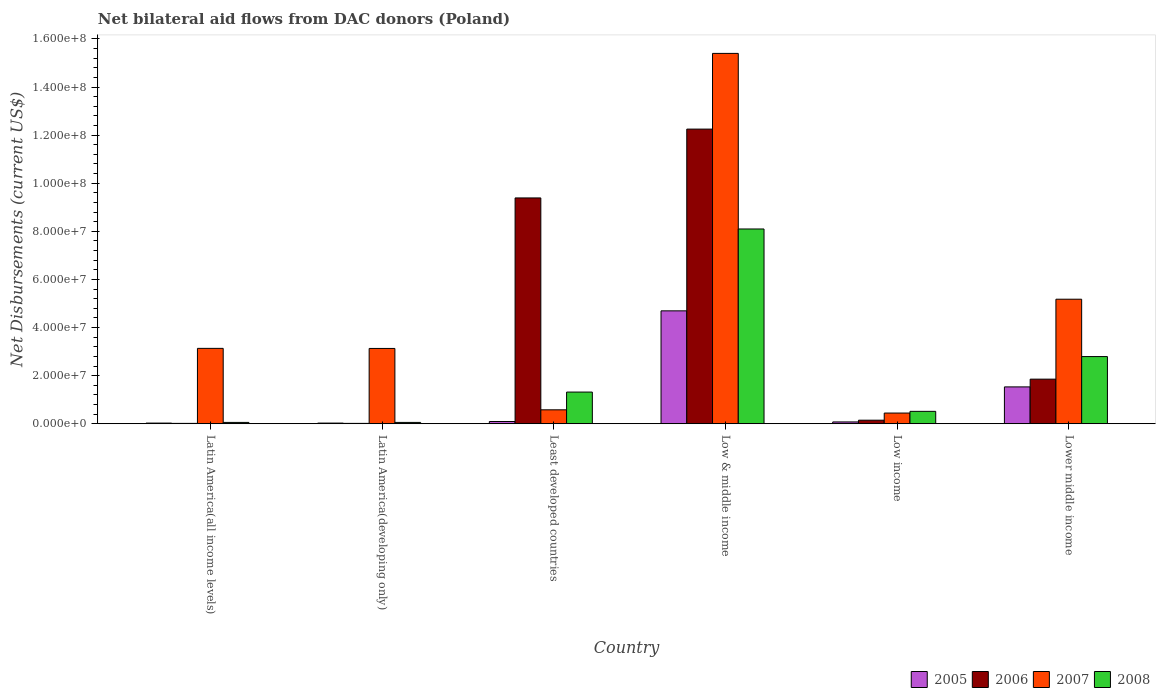How many groups of bars are there?
Provide a succinct answer. 6. Are the number of bars per tick equal to the number of legend labels?
Your answer should be compact. Yes. How many bars are there on the 2nd tick from the left?
Your response must be concise. 4. What is the label of the 2nd group of bars from the left?
Make the answer very short. Latin America(developing only). What is the net bilateral aid flows in 2005 in Low income?
Your answer should be very brief. 7.50e+05. Across all countries, what is the maximum net bilateral aid flows in 2008?
Offer a very short reply. 8.10e+07. In which country was the net bilateral aid flows in 2006 maximum?
Offer a terse response. Low & middle income. In which country was the net bilateral aid flows in 2008 minimum?
Keep it short and to the point. Latin America(all income levels). What is the total net bilateral aid flows in 2007 in the graph?
Your response must be concise. 2.79e+08. What is the difference between the net bilateral aid flows in 2005 in Least developed countries and the net bilateral aid flows in 2008 in Low & middle income?
Make the answer very short. -8.00e+07. What is the average net bilateral aid flows in 2005 per country?
Make the answer very short. 1.07e+07. What is the difference between the net bilateral aid flows of/in 2006 and net bilateral aid flows of/in 2008 in Low & middle income?
Ensure brevity in your answer.  4.15e+07. In how many countries, is the net bilateral aid flows in 2008 greater than 88000000 US$?
Your response must be concise. 0. What is the ratio of the net bilateral aid flows in 2007 in Latin America(all income levels) to that in Latin America(developing only)?
Offer a terse response. 1. Is the net bilateral aid flows in 2008 in Latin America(developing only) less than that in Lower middle income?
Keep it short and to the point. Yes. Is the difference between the net bilateral aid flows in 2006 in Latin America(all income levels) and Latin America(developing only) greater than the difference between the net bilateral aid flows in 2008 in Latin America(all income levels) and Latin America(developing only)?
Ensure brevity in your answer.  No. What is the difference between the highest and the second highest net bilateral aid flows in 2008?
Make the answer very short. 6.78e+07. What is the difference between the highest and the lowest net bilateral aid flows in 2007?
Your response must be concise. 1.50e+08. Is the sum of the net bilateral aid flows in 2007 in Least developed countries and Low income greater than the maximum net bilateral aid flows in 2005 across all countries?
Provide a short and direct response. No. Is it the case that in every country, the sum of the net bilateral aid flows in 2008 and net bilateral aid flows in 2006 is greater than the sum of net bilateral aid flows in 2005 and net bilateral aid flows in 2007?
Your answer should be compact. No. What does the 4th bar from the left in Low & middle income represents?
Give a very brief answer. 2008. Is it the case that in every country, the sum of the net bilateral aid flows in 2007 and net bilateral aid flows in 2005 is greater than the net bilateral aid flows in 2006?
Provide a short and direct response. No. Are all the bars in the graph horizontal?
Offer a very short reply. No. How many countries are there in the graph?
Your answer should be very brief. 6. Are the values on the major ticks of Y-axis written in scientific E-notation?
Offer a terse response. Yes. Where does the legend appear in the graph?
Make the answer very short. Bottom right. How many legend labels are there?
Your response must be concise. 4. How are the legend labels stacked?
Provide a succinct answer. Horizontal. What is the title of the graph?
Offer a very short reply. Net bilateral aid flows from DAC donors (Poland). What is the label or title of the X-axis?
Make the answer very short. Country. What is the label or title of the Y-axis?
Ensure brevity in your answer.  Net Disbursements (current US$). What is the Net Disbursements (current US$) of 2007 in Latin America(all income levels)?
Give a very brief answer. 3.13e+07. What is the Net Disbursements (current US$) of 2005 in Latin America(developing only)?
Make the answer very short. 2.70e+05. What is the Net Disbursements (current US$) in 2007 in Latin America(developing only)?
Provide a short and direct response. 3.13e+07. What is the Net Disbursements (current US$) of 2008 in Latin America(developing only)?
Your response must be concise. 5.50e+05. What is the Net Disbursements (current US$) of 2005 in Least developed countries?
Offer a terse response. 9.30e+05. What is the Net Disbursements (current US$) of 2006 in Least developed countries?
Keep it short and to the point. 9.39e+07. What is the Net Disbursements (current US$) in 2007 in Least developed countries?
Offer a very short reply. 5.79e+06. What is the Net Disbursements (current US$) of 2008 in Least developed countries?
Your answer should be compact. 1.32e+07. What is the Net Disbursements (current US$) of 2005 in Low & middle income?
Offer a terse response. 4.69e+07. What is the Net Disbursements (current US$) in 2006 in Low & middle income?
Provide a short and direct response. 1.23e+08. What is the Net Disbursements (current US$) of 2007 in Low & middle income?
Offer a terse response. 1.54e+08. What is the Net Disbursements (current US$) in 2008 in Low & middle income?
Give a very brief answer. 8.10e+07. What is the Net Disbursements (current US$) of 2005 in Low income?
Offer a terse response. 7.50e+05. What is the Net Disbursements (current US$) in 2006 in Low income?
Provide a short and direct response. 1.47e+06. What is the Net Disbursements (current US$) of 2007 in Low income?
Make the answer very short. 4.44e+06. What is the Net Disbursements (current US$) of 2008 in Low income?
Ensure brevity in your answer.  5.15e+06. What is the Net Disbursements (current US$) of 2005 in Lower middle income?
Provide a succinct answer. 1.53e+07. What is the Net Disbursements (current US$) in 2006 in Lower middle income?
Provide a short and direct response. 1.85e+07. What is the Net Disbursements (current US$) in 2007 in Lower middle income?
Give a very brief answer. 5.18e+07. What is the Net Disbursements (current US$) of 2008 in Lower middle income?
Keep it short and to the point. 2.79e+07. Across all countries, what is the maximum Net Disbursements (current US$) in 2005?
Ensure brevity in your answer.  4.69e+07. Across all countries, what is the maximum Net Disbursements (current US$) in 2006?
Your answer should be compact. 1.23e+08. Across all countries, what is the maximum Net Disbursements (current US$) in 2007?
Provide a short and direct response. 1.54e+08. Across all countries, what is the maximum Net Disbursements (current US$) in 2008?
Your response must be concise. 8.10e+07. Across all countries, what is the minimum Net Disbursements (current US$) of 2005?
Your answer should be very brief. 2.70e+05. Across all countries, what is the minimum Net Disbursements (current US$) in 2006?
Your response must be concise. 1.50e+05. Across all countries, what is the minimum Net Disbursements (current US$) of 2007?
Your response must be concise. 4.44e+06. Across all countries, what is the minimum Net Disbursements (current US$) of 2008?
Ensure brevity in your answer.  5.50e+05. What is the total Net Disbursements (current US$) in 2005 in the graph?
Provide a short and direct response. 6.45e+07. What is the total Net Disbursements (current US$) of 2006 in the graph?
Provide a succinct answer. 2.37e+08. What is the total Net Disbursements (current US$) of 2007 in the graph?
Your answer should be very brief. 2.79e+08. What is the total Net Disbursements (current US$) in 2008 in the graph?
Your answer should be very brief. 1.28e+08. What is the difference between the Net Disbursements (current US$) of 2005 in Latin America(all income levels) and that in Latin America(developing only)?
Offer a terse response. 0. What is the difference between the Net Disbursements (current US$) in 2006 in Latin America(all income levels) and that in Latin America(developing only)?
Provide a short and direct response. 0. What is the difference between the Net Disbursements (current US$) in 2007 in Latin America(all income levels) and that in Latin America(developing only)?
Your answer should be compact. 3.00e+04. What is the difference between the Net Disbursements (current US$) of 2008 in Latin America(all income levels) and that in Latin America(developing only)?
Your response must be concise. 0. What is the difference between the Net Disbursements (current US$) in 2005 in Latin America(all income levels) and that in Least developed countries?
Ensure brevity in your answer.  -6.60e+05. What is the difference between the Net Disbursements (current US$) of 2006 in Latin America(all income levels) and that in Least developed countries?
Ensure brevity in your answer.  -9.37e+07. What is the difference between the Net Disbursements (current US$) of 2007 in Latin America(all income levels) and that in Least developed countries?
Your answer should be compact. 2.56e+07. What is the difference between the Net Disbursements (current US$) of 2008 in Latin America(all income levels) and that in Least developed countries?
Your response must be concise. -1.26e+07. What is the difference between the Net Disbursements (current US$) of 2005 in Latin America(all income levels) and that in Low & middle income?
Make the answer very short. -4.67e+07. What is the difference between the Net Disbursements (current US$) in 2006 in Latin America(all income levels) and that in Low & middle income?
Your response must be concise. -1.22e+08. What is the difference between the Net Disbursements (current US$) in 2007 in Latin America(all income levels) and that in Low & middle income?
Your answer should be very brief. -1.23e+08. What is the difference between the Net Disbursements (current US$) in 2008 in Latin America(all income levels) and that in Low & middle income?
Keep it short and to the point. -8.04e+07. What is the difference between the Net Disbursements (current US$) of 2005 in Latin America(all income levels) and that in Low income?
Provide a succinct answer. -4.80e+05. What is the difference between the Net Disbursements (current US$) of 2006 in Latin America(all income levels) and that in Low income?
Your answer should be compact. -1.32e+06. What is the difference between the Net Disbursements (current US$) in 2007 in Latin America(all income levels) and that in Low income?
Provide a short and direct response. 2.69e+07. What is the difference between the Net Disbursements (current US$) of 2008 in Latin America(all income levels) and that in Low income?
Offer a terse response. -4.60e+06. What is the difference between the Net Disbursements (current US$) in 2005 in Latin America(all income levels) and that in Lower middle income?
Make the answer very short. -1.50e+07. What is the difference between the Net Disbursements (current US$) of 2006 in Latin America(all income levels) and that in Lower middle income?
Your answer should be compact. -1.84e+07. What is the difference between the Net Disbursements (current US$) in 2007 in Latin America(all income levels) and that in Lower middle income?
Keep it short and to the point. -2.04e+07. What is the difference between the Net Disbursements (current US$) of 2008 in Latin America(all income levels) and that in Lower middle income?
Your answer should be very brief. -2.74e+07. What is the difference between the Net Disbursements (current US$) in 2005 in Latin America(developing only) and that in Least developed countries?
Make the answer very short. -6.60e+05. What is the difference between the Net Disbursements (current US$) of 2006 in Latin America(developing only) and that in Least developed countries?
Ensure brevity in your answer.  -9.37e+07. What is the difference between the Net Disbursements (current US$) in 2007 in Latin America(developing only) and that in Least developed countries?
Offer a terse response. 2.55e+07. What is the difference between the Net Disbursements (current US$) in 2008 in Latin America(developing only) and that in Least developed countries?
Ensure brevity in your answer.  -1.26e+07. What is the difference between the Net Disbursements (current US$) in 2005 in Latin America(developing only) and that in Low & middle income?
Offer a very short reply. -4.67e+07. What is the difference between the Net Disbursements (current US$) of 2006 in Latin America(developing only) and that in Low & middle income?
Provide a short and direct response. -1.22e+08. What is the difference between the Net Disbursements (current US$) of 2007 in Latin America(developing only) and that in Low & middle income?
Offer a very short reply. -1.23e+08. What is the difference between the Net Disbursements (current US$) in 2008 in Latin America(developing only) and that in Low & middle income?
Keep it short and to the point. -8.04e+07. What is the difference between the Net Disbursements (current US$) of 2005 in Latin America(developing only) and that in Low income?
Offer a terse response. -4.80e+05. What is the difference between the Net Disbursements (current US$) of 2006 in Latin America(developing only) and that in Low income?
Provide a succinct answer. -1.32e+06. What is the difference between the Net Disbursements (current US$) of 2007 in Latin America(developing only) and that in Low income?
Offer a very short reply. 2.69e+07. What is the difference between the Net Disbursements (current US$) of 2008 in Latin America(developing only) and that in Low income?
Ensure brevity in your answer.  -4.60e+06. What is the difference between the Net Disbursements (current US$) in 2005 in Latin America(developing only) and that in Lower middle income?
Your answer should be compact. -1.50e+07. What is the difference between the Net Disbursements (current US$) in 2006 in Latin America(developing only) and that in Lower middle income?
Make the answer very short. -1.84e+07. What is the difference between the Net Disbursements (current US$) in 2007 in Latin America(developing only) and that in Lower middle income?
Your answer should be compact. -2.05e+07. What is the difference between the Net Disbursements (current US$) in 2008 in Latin America(developing only) and that in Lower middle income?
Your answer should be compact. -2.74e+07. What is the difference between the Net Disbursements (current US$) in 2005 in Least developed countries and that in Low & middle income?
Keep it short and to the point. -4.60e+07. What is the difference between the Net Disbursements (current US$) of 2006 in Least developed countries and that in Low & middle income?
Make the answer very short. -2.86e+07. What is the difference between the Net Disbursements (current US$) of 2007 in Least developed countries and that in Low & middle income?
Make the answer very short. -1.48e+08. What is the difference between the Net Disbursements (current US$) in 2008 in Least developed countries and that in Low & middle income?
Your response must be concise. -6.78e+07. What is the difference between the Net Disbursements (current US$) in 2006 in Least developed countries and that in Low income?
Your answer should be very brief. 9.24e+07. What is the difference between the Net Disbursements (current US$) of 2007 in Least developed countries and that in Low income?
Your answer should be compact. 1.35e+06. What is the difference between the Net Disbursements (current US$) of 2008 in Least developed countries and that in Low income?
Your answer should be very brief. 8.02e+06. What is the difference between the Net Disbursements (current US$) of 2005 in Least developed countries and that in Lower middle income?
Provide a short and direct response. -1.44e+07. What is the difference between the Net Disbursements (current US$) in 2006 in Least developed countries and that in Lower middle income?
Offer a very short reply. 7.54e+07. What is the difference between the Net Disbursements (current US$) in 2007 in Least developed countries and that in Lower middle income?
Give a very brief answer. -4.60e+07. What is the difference between the Net Disbursements (current US$) of 2008 in Least developed countries and that in Lower middle income?
Your answer should be compact. -1.48e+07. What is the difference between the Net Disbursements (current US$) of 2005 in Low & middle income and that in Low income?
Provide a succinct answer. 4.62e+07. What is the difference between the Net Disbursements (current US$) of 2006 in Low & middle income and that in Low income?
Provide a short and direct response. 1.21e+08. What is the difference between the Net Disbursements (current US$) of 2007 in Low & middle income and that in Low income?
Provide a short and direct response. 1.50e+08. What is the difference between the Net Disbursements (current US$) in 2008 in Low & middle income and that in Low income?
Offer a very short reply. 7.58e+07. What is the difference between the Net Disbursements (current US$) of 2005 in Low & middle income and that in Lower middle income?
Your answer should be compact. 3.16e+07. What is the difference between the Net Disbursements (current US$) in 2006 in Low & middle income and that in Lower middle income?
Provide a succinct answer. 1.04e+08. What is the difference between the Net Disbursements (current US$) of 2007 in Low & middle income and that in Lower middle income?
Your response must be concise. 1.02e+08. What is the difference between the Net Disbursements (current US$) of 2008 in Low & middle income and that in Lower middle income?
Ensure brevity in your answer.  5.30e+07. What is the difference between the Net Disbursements (current US$) in 2005 in Low income and that in Lower middle income?
Provide a succinct answer. -1.46e+07. What is the difference between the Net Disbursements (current US$) of 2006 in Low income and that in Lower middle income?
Your answer should be compact. -1.71e+07. What is the difference between the Net Disbursements (current US$) in 2007 in Low income and that in Lower middle income?
Make the answer very short. -4.73e+07. What is the difference between the Net Disbursements (current US$) in 2008 in Low income and that in Lower middle income?
Provide a succinct answer. -2.28e+07. What is the difference between the Net Disbursements (current US$) of 2005 in Latin America(all income levels) and the Net Disbursements (current US$) of 2006 in Latin America(developing only)?
Your answer should be compact. 1.20e+05. What is the difference between the Net Disbursements (current US$) in 2005 in Latin America(all income levels) and the Net Disbursements (current US$) in 2007 in Latin America(developing only)?
Provide a succinct answer. -3.10e+07. What is the difference between the Net Disbursements (current US$) of 2005 in Latin America(all income levels) and the Net Disbursements (current US$) of 2008 in Latin America(developing only)?
Your response must be concise. -2.80e+05. What is the difference between the Net Disbursements (current US$) in 2006 in Latin America(all income levels) and the Net Disbursements (current US$) in 2007 in Latin America(developing only)?
Make the answer very short. -3.12e+07. What is the difference between the Net Disbursements (current US$) of 2006 in Latin America(all income levels) and the Net Disbursements (current US$) of 2008 in Latin America(developing only)?
Your answer should be compact. -4.00e+05. What is the difference between the Net Disbursements (current US$) in 2007 in Latin America(all income levels) and the Net Disbursements (current US$) in 2008 in Latin America(developing only)?
Offer a very short reply. 3.08e+07. What is the difference between the Net Disbursements (current US$) in 2005 in Latin America(all income levels) and the Net Disbursements (current US$) in 2006 in Least developed countries?
Offer a very short reply. -9.36e+07. What is the difference between the Net Disbursements (current US$) in 2005 in Latin America(all income levels) and the Net Disbursements (current US$) in 2007 in Least developed countries?
Provide a short and direct response. -5.52e+06. What is the difference between the Net Disbursements (current US$) in 2005 in Latin America(all income levels) and the Net Disbursements (current US$) in 2008 in Least developed countries?
Offer a very short reply. -1.29e+07. What is the difference between the Net Disbursements (current US$) of 2006 in Latin America(all income levels) and the Net Disbursements (current US$) of 2007 in Least developed countries?
Provide a succinct answer. -5.64e+06. What is the difference between the Net Disbursements (current US$) in 2006 in Latin America(all income levels) and the Net Disbursements (current US$) in 2008 in Least developed countries?
Provide a short and direct response. -1.30e+07. What is the difference between the Net Disbursements (current US$) of 2007 in Latin America(all income levels) and the Net Disbursements (current US$) of 2008 in Least developed countries?
Your response must be concise. 1.82e+07. What is the difference between the Net Disbursements (current US$) of 2005 in Latin America(all income levels) and the Net Disbursements (current US$) of 2006 in Low & middle income?
Ensure brevity in your answer.  -1.22e+08. What is the difference between the Net Disbursements (current US$) in 2005 in Latin America(all income levels) and the Net Disbursements (current US$) in 2007 in Low & middle income?
Your response must be concise. -1.54e+08. What is the difference between the Net Disbursements (current US$) in 2005 in Latin America(all income levels) and the Net Disbursements (current US$) in 2008 in Low & middle income?
Your answer should be very brief. -8.07e+07. What is the difference between the Net Disbursements (current US$) in 2006 in Latin America(all income levels) and the Net Disbursements (current US$) in 2007 in Low & middle income?
Make the answer very short. -1.54e+08. What is the difference between the Net Disbursements (current US$) in 2006 in Latin America(all income levels) and the Net Disbursements (current US$) in 2008 in Low & middle income?
Ensure brevity in your answer.  -8.08e+07. What is the difference between the Net Disbursements (current US$) in 2007 in Latin America(all income levels) and the Net Disbursements (current US$) in 2008 in Low & middle income?
Your response must be concise. -4.96e+07. What is the difference between the Net Disbursements (current US$) in 2005 in Latin America(all income levels) and the Net Disbursements (current US$) in 2006 in Low income?
Offer a very short reply. -1.20e+06. What is the difference between the Net Disbursements (current US$) of 2005 in Latin America(all income levels) and the Net Disbursements (current US$) of 2007 in Low income?
Ensure brevity in your answer.  -4.17e+06. What is the difference between the Net Disbursements (current US$) of 2005 in Latin America(all income levels) and the Net Disbursements (current US$) of 2008 in Low income?
Give a very brief answer. -4.88e+06. What is the difference between the Net Disbursements (current US$) of 2006 in Latin America(all income levels) and the Net Disbursements (current US$) of 2007 in Low income?
Make the answer very short. -4.29e+06. What is the difference between the Net Disbursements (current US$) in 2006 in Latin America(all income levels) and the Net Disbursements (current US$) in 2008 in Low income?
Your answer should be very brief. -5.00e+06. What is the difference between the Net Disbursements (current US$) of 2007 in Latin America(all income levels) and the Net Disbursements (current US$) of 2008 in Low income?
Your answer should be compact. 2.62e+07. What is the difference between the Net Disbursements (current US$) in 2005 in Latin America(all income levels) and the Net Disbursements (current US$) in 2006 in Lower middle income?
Provide a short and direct response. -1.83e+07. What is the difference between the Net Disbursements (current US$) of 2005 in Latin America(all income levels) and the Net Disbursements (current US$) of 2007 in Lower middle income?
Offer a very short reply. -5.15e+07. What is the difference between the Net Disbursements (current US$) in 2005 in Latin America(all income levels) and the Net Disbursements (current US$) in 2008 in Lower middle income?
Offer a very short reply. -2.77e+07. What is the difference between the Net Disbursements (current US$) of 2006 in Latin America(all income levels) and the Net Disbursements (current US$) of 2007 in Lower middle income?
Your answer should be compact. -5.16e+07. What is the difference between the Net Disbursements (current US$) in 2006 in Latin America(all income levels) and the Net Disbursements (current US$) in 2008 in Lower middle income?
Give a very brief answer. -2.78e+07. What is the difference between the Net Disbursements (current US$) in 2007 in Latin America(all income levels) and the Net Disbursements (current US$) in 2008 in Lower middle income?
Ensure brevity in your answer.  3.41e+06. What is the difference between the Net Disbursements (current US$) of 2005 in Latin America(developing only) and the Net Disbursements (current US$) of 2006 in Least developed countries?
Your answer should be compact. -9.36e+07. What is the difference between the Net Disbursements (current US$) in 2005 in Latin America(developing only) and the Net Disbursements (current US$) in 2007 in Least developed countries?
Give a very brief answer. -5.52e+06. What is the difference between the Net Disbursements (current US$) in 2005 in Latin America(developing only) and the Net Disbursements (current US$) in 2008 in Least developed countries?
Offer a very short reply. -1.29e+07. What is the difference between the Net Disbursements (current US$) of 2006 in Latin America(developing only) and the Net Disbursements (current US$) of 2007 in Least developed countries?
Offer a terse response. -5.64e+06. What is the difference between the Net Disbursements (current US$) in 2006 in Latin America(developing only) and the Net Disbursements (current US$) in 2008 in Least developed countries?
Offer a terse response. -1.30e+07. What is the difference between the Net Disbursements (current US$) in 2007 in Latin America(developing only) and the Net Disbursements (current US$) in 2008 in Least developed countries?
Give a very brief answer. 1.81e+07. What is the difference between the Net Disbursements (current US$) in 2005 in Latin America(developing only) and the Net Disbursements (current US$) in 2006 in Low & middle income?
Your answer should be compact. -1.22e+08. What is the difference between the Net Disbursements (current US$) of 2005 in Latin America(developing only) and the Net Disbursements (current US$) of 2007 in Low & middle income?
Ensure brevity in your answer.  -1.54e+08. What is the difference between the Net Disbursements (current US$) of 2005 in Latin America(developing only) and the Net Disbursements (current US$) of 2008 in Low & middle income?
Offer a very short reply. -8.07e+07. What is the difference between the Net Disbursements (current US$) of 2006 in Latin America(developing only) and the Net Disbursements (current US$) of 2007 in Low & middle income?
Provide a succinct answer. -1.54e+08. What is the difference between the Net Disbursements (current US$) of 2006 in Latin America(developing only) and the Net Disbursements (current US$) of 2008 in Low & middle income?
Provide a short and direct response. -8.08e+07. What is the difference between the Net Disbursements (current US$) in 2007 in Latin America(developing only) and the Net Disbursements (current US$) in 2008 in Low & middle income?
Your answer should be very brief. -4.97e+07. What is the difference between the Net Disbursements (current US$) in 2005 in Latin America(developing only) and the Net Disbursements (current US$) in 2006 in Low income?
Your response must be concise. -1.20e+06. What is the difference between the Net Disbursements (current US$) in 2005 in Latin America(developing only) and the Net Disbursements (current US$) in 2007 in Low income?
Your response must be concise. -4.17e+06. What is the difference between the Net Disbursements (current US$) of 2005 in Latin America(developing only) and the Net Disbursements (current US$) of 2008 in Low income?
Provide a short and direct response. -4.88e+06. What is the difference between the Net Disbursements (current US$) of 2006 in Latin America(developing only) and the Net Disbursements (current US$) of 2007 in Low income?
Provide a succinct answer. -4.29e+06. What is the difference between the Net Disbursements (current US$) of 2006 in Latin America(developing only) and the Net Disbursements (current US$) of 2008 in Low income?
Your answer should be compact. -5.00e+06. What is the difference between the Net Disbursements (current US$) of 2007 in Latin America(developing only) and the Net Disbursements (current US$) of 2008 in Low income?
Ensure brevity in your answer.  2.62e+07. What is the difference between the Net Disbursements (current US$) in 2005 in Latin America(developing only) and the Net Disbursements (current US$) in 2006 in Lower middle income?
Offer a terse response. -1.83e+07. What is the difference between the Net Disbursements (current US$) in 2005 in Latin America(developing only) and the Net Disbursements (current US$) in 2007 in Lower middle income?
Make the answer very short. -5.15e+07. What is the difference between the Net Disbursements (current US$) of 2005 in Latin America(developing only) and the Net Disbursements (current US$) of 2008 in Lower middle income?
Give a very brief answer. -2.77e+07. What is the difference between the Net Disbursements (current US$) in 2006 in Latin America(developing only) and the Net Disbursements (current US$) in 2007 in Lower middle income?
Keep it short and to the point. -5.16e+07. What is the difference between the Net Disbursements (current US$) of 2006 in Latin America(developing only) and the Net Disbursements (current US$) of 2008 in Lower middle income?
Ensure brevity in your answer.  -2.78e+07. What is the difference between the Net Disbursements (current US$) in 2007 in Latin America(developing only) and the Net Disbursements (current US$) in 2008 in Lower middle income?
Keep it short and to the point. 3.38e+06. What is the difference between the Net Disbursements (current US$) in 2005 in Least developed countries and the Net Disbursements (current US$) in 2006 in Low & middle income?
Make the answer very short. -1.22e+08. What is the difference between the Net Disbursements (current US$) of 2005 in Least developed countries and the Net Disbursements (current US$) of 2007 in Low & middle income?
Offer a terse response. -1.53e+08. What is the difference between the Net Disbursements (current US$) of 2005 in Least developed countries and the Net Disbursements (current US$) of 2008 in Low & middle income?
Your answer should be compact. -8.00e+07. What is the difference between the Net Disbursements (current US$) in 2006 in Least developed countries and the Net Disbursements (current US$) in 2007 in Low & middle income?
Your answer should be compact. -6.01e+07. What is the difference between the Net Disbursements (current US$) in 2006 in Least developed countries and the Net Disbursements (current US$) in 2008 in Low & middle income?
Ensure brevity in your answer.  1.29e+07. What is the difference between the Net Disbursements (current US$) in 2007 in Least developed countries and the Net Disbursements (current US$) in 2008 in Low & middle income?
Your answer should be very brief. -7.52e+07. What is the difference between the Net Disbursements (current US$) in 2005 in Least developed countries and the Net Disbursements (current US$) in 2006 in Low income?
Provide a short and direct response. -5.40e+05. What is the difference between the Net Disbursements (current US$) in 2005 in Least developed countries and the Net Disbursements (current US$) in 2007 in Low income?
Your answer should be compact. -3.51e+06. What is the difference between the Net Disbursements (current US$) of 2005 in Least developed countries and the Net Disbursements (current US$) of 2008 in Low income?
Provide a short and direct response. -4.22e+06. What is the difference between the Net Disbursements (current US$) in 2006 in Least developed countries and the Net Disbursements (current US$) in 2007 in Low income?
Give a very brief answer. 8.94e+07. What is the difference between the Net Disbursements (current US$) of 2006 in Least developed countries and the Net Disbursements (current US$) of 2008 in Low income?
Give a very brief answer. 8.87e+07. What is the difference between the Net Disbursements (current US$) in 2007 in Least developed countries and the Net Disbursements (current US$) in 2008 in Low income?
Give a very brief answer. 6.40e+05. What is the difference between the Net Disbursements (current US$) in 2005 in Least developed countries and the Net Disbursements (current US$) in 2006 in Lower middle income?
Offer a very short reply. -1.76e+07. What is the difference between the Net Disbursements (current US$) of 2005 in Least developed countries and the Net Disbursements (current US$) of 2007 in Lower middle income?
Provide a short and direct response. -5.08e+07. What is the difference between the Net Disbursements (current US$) in 2005 in Least developed countries and the Net Disbursements (current US$) in 2008 in Lower middle income?
Your answer should be very brief. -2.70e+07. What is the difference between the Net Disbursements (current US$) of 2006 in Least developed countries and the Net Disbursements (current US$) of 2007 in Lower middle income?
Ensure brevity in your answer.  4.21e+07. What is the difference between the Net Disbursements (current US$) of 2006 in Least developed countries and the Net Disbursements (current US$) of 2008 in Lower middle income?
Give a very brief answer. 6.60e+07. What is the difference between the Net Disbursements (current US$) of 2007 in Least developed countries and the Net Disbursements (current US$) of 2008 in Lower middle income?
Ensure brevity in your answer.  -2.21e+07. What is the difference between the Net Disbursements (current US$) of 2005 in Low & middle income and the Net Disbursements (current US$) of 2006 in Low income?
Your response must be concise. 4.55e+07. What is the difference between the Net Disbursements (current US$) in 2005 in Low & middle income and the Net Disbursements (current US$) in 2007 in Low income?
Offer a terse response. 4.25e+07. What is the difference between the Net Disbursements (current US$) in 2005 in Low & middle income and the Net Disbursements (current US$) in 2008 in Low income?
Your answer should be very brief. 4.18e+07. What is the difference between the Net Disbursements (current US$) in 2006 in Low & middle income and the Net Disbursements (current US$) in 2007 in Low income?
Make the answer very short. 1.18e+08. What is the difference between the Net Disbursements (current US$) in 2006 in Low & middle income and the Net Disbursements (current US$) in 2008 in Low income?
Offer a very short reply. 1.17e+08. What is the difference between the Net Disbursements (current US$) in 2007 in Low & middle income and the Net Disbursements (current US$) in 2008 in Low income?
Make the answer very short. 1.49e+08. What is the difference between the Net Disbursements (current US$) of 2005 in Low & middle income and the Net Disbursements (current US$) of 2006 in Lower middle income?
Your answer should be very brief. 2.84e+07. What is the difference between the Net Disbursements (current US$) in 2005 in Low & middle income and the Net Disbursements (current US$) in 2007 in Lower middle income?
Ensure brevity in your answer.  -4.84e+06. What is the difference between the Net Disbursements (current US$) of 2005 in Low & middle income and the Net Disbursements (current US$) of 2008 in Lower middle income?
Keep it short and to the point. 1.90e+07. What is the difference between the Net Disbursements (current US$) in 2006 in Low & middle income and the Net Disbursements (current US$) in 2007 in Lower middle income?
Offer a very short reply. 7.07e+07. What is the difference between the Net Disbursements (current US$) of 2006 in Low & middle income and the Net Disbursements (current US$) of 2008 in Lower middle income?
Your answer should be very brief. 9.46e+07. What is the difference between the Net Disbursements (current US$) of 2007 in Low & middle income and the Net Disbursements (current US$) of 2008 in Lower middle income?
Offer a terse response. 1.26e+08. What is the difference between the Net Disbursements (current US$) of 2005 in Low income and the Net Disbursements (current US$) of 2006 in Lower middle income?
Your answer should be very brief. -1.78e+07. What is the difference between the Net Disbursements (current US$) of 2005 in Low income and the Net Disbursements (current US$) of 2007 in Lower middle income?
Your response must be concise. -5.10e+07. What is the difference between the Net Disbursements (current US$) of 2005 in Low income and the Net Disbursements (current US$) of 2008 in Lower middle income?
Make the answer very short. -2.72e+07. What is the difference between the Net Disbursements (current US$) of 2006 in Low income and the Net Disbursements (current US$) of 2007 in Lower middle income?
Provide a succinct answer. -5.03e+07. What is the difference between the Net Disbursements (current US$) of 2006 in Low income and the Net Disbursements (current US$) of 2008 in Lower middle income?
Your answer should be compact. -2.65e+07. What is the difference between the Net Disbursements (current US$) in 2007 in Low income and the Net Disbursements (current US$) in 2008 in Lower middle income?
Your response must be concise. -2.35e+07. What is the average Net Disbursements (current US$) in 2005 per country?
Provide a succinct answer. 1.07e+07. What is the average Net Disbursements (current US$) in 2006 per country?
Give a very brief answer. 3.95e+07. What is the average Net Disbursements (current US$) in 2007 per country?
Provide a short and direct response. 4.64e+07. What is the average Net Disbursements (current US$) of 2008 per country?
Offer a very short reply. 2.14e+07. What is the difference between the Net Disbursements (current US$) in 2005 and Net Disbursements (current US$) in 2007 in Latin America(all income levels)?
Provide a succinct answer. -3.11e+07. What is the difference between the Net Disbursements (current US$) in 2005 and Net Disbursements (current US$) in 2008 in Latin America(all income levels)?
Provide a succinct answer. -2.80e+05. What is the difference between the Net Disbursements (current US$) in 2006 and Net Disbursements (current US$) in 2007 in Latin America(all income levels)?
Your answer should be very brief. -3.12e+07. What is the difference between the Net Disbursements (current US$) in 2006 and Net Disbursements (current US$) in 2008 in Latin America(all income levels)?
Offer a terse response. -4.00e+05. What is the difference between the Net Disbursements (current US$) of 2007 and Net Disbursements (current US$) of 2008 in Latin America(all income levels)?
Give a very brief answer. 3.08e+07. What is the difference between the Net Disbursements (current US$) in 2005 and Net Disbursements (current US$) in 2007 in Latin America(developing only)?
Provide a short and direct response. -3.10e+07. What is the difference between the Net Disbursements (current US$) of 2005 and Net Disbursements (current US$) of 2008 in Latin America(developing only)?
Provide a short and direct response. -2.80e+05. What is the difference between the Net Disbursements (current US$) in 2006 and Net Disbursements (current US$) in 2007 in Latin America(developing only)?
Provide a short and direct response. -3.12e+07. What is the difference between the Net Disbursements (current US$) of 2006 and Net Disbursements (current US$) of 2008 in Latin America(developing only)?
Your answer should be compact. -4.00e+05. What is the difference between the Net Disbursements (current US$) in 2007 and Net Disbursements (current US$) in 2008 in Latin America(developing only)?
Offer a terse response. 3.08e+07. What is the difference between the Net Disbursements (current US$) of 2005 and Net Disbursements (current US$) of 2006 in Least developed countries?
Ensure brevity in your answer.  -9.30e+07. What is the difference between the Net Disbursements (current US$) in 2005 and Net Disbursements (current US$) in 2007 in Least developed countries?
Give a very brief answer. -4.86e+06. What is the difference between the Net Disbursements (current US$) in 2005 and Net Disbursements (current US$) in 2008 in Least developed countries?
Provide a short and direct response. -1.22e+07. What is the difference between the Net Disbursements (current US$) of 2006 and Net Disbursements (current US$) of 2007 in Least developed countries?
Your answer should be compact. 8.81e+07. What is the difference between the Net Disbursements (current US$) in 2006 and Net Disbursements (current US$) in 2008 in Least developed countries?
Make the answer very short. 8.07e+07. What is the difference between the Net Disbursements (current US$) of 2007 and Net Disbursements (current US$) of 2008 in Least developed countries?
Your answer should be very brief. -7.38e+06. What is the difference between the Net Disbursements (current US$) of 2005 and Net Disbursements (current US$) of 2006 in Low & middle income?
Provide a short and direct response. -7.56e+07. What is the difference between the Net Disbursements (current US$) of 2005 and Net Disbursements (current US$) of 2007 in Low & middle income?
Provide a short and direct response. -1.07e+08. What is the difference between the Net Disbursements (current US$) in 2005 and Net Disbursements (current US$) in 2008 in Low & middle income?
Offer a terse response. -3.40e+07. What is the difference between the Net Disbursements (current US$) in 2006 and Net Disbursements (current US$) in 2007 in Low & middle income?
Ensure brevity in your answer.  -3.15e+07. What is the difference between the Net Disbursements (current US$) in 2006 and Net Disbursements (current US$) in 2008 in Low & middle income?
Your response must be concise. 4.15e+07. What is the difference between the Net Disbursements (current US$) in 2007 and Net Disbursements (current US$) in 2008 in Low & middle income?
Provide a succinct answer. 7.30e+07. What is the difference between the Net Disbursements (current US$) in 2005 and Net Disbursements (current US$) in 2006 in Low income?
Make the answer very short. -7.20e+05. What is the difference between the Net Disbursements (current US$) in 2005 and Net Disbursements (current US$) in 2007 in Low income?
Offer a very short reply. -3.69e+06. What is the difference between the Net Disbursements (current US$) in 2005 and Net Disbursements (current US$) in 2008 in Low income?
Offer a terse response. -4.40e+06. What is the difference between the Net Disbursements (current US$) of 2006 and Net Disbursements (current US$) of 2007 in Low income?
Provide a succinct answer. -2.97e+06. What is the difference between the Net Disbursements (current US$) in 2006 and Net Disbursements (current US$) in 2008 in Low income?
Offer a very short reply. -3.68e+06. What is the difference between the Net Disbursements (current US$) of 2007 and Net Disbursements (current US$) of 2008 in Low income?
Provide a succinct answer. -7.10e+05. What is the difference between the Net Disbursements (current US$) of 2005 and Net Disbursements (current US$) of 2006 in Lower middle income?
Offer a terse response. -3.22e+06. What is the difference between the Net Disbursements (current US$) in 2005 and Net Disbursements (current US$) in 2007 in Lower middle income?
Provide a short and direct response. -3.65e+07. What is the difference between the Net Disbursements (current US$) of 2005 and Net Disbursements (current US$) of 2008 in Lower middle income?
Keep it short and to the point. -1.26e+07. What is the difference between the Net Disbursements (current US$) of 2006 and Net Disbursements (current US$) of 2007 in Lower middle income?
Offer a terse response. -3.32e+07. What is the difference between the Net Disbursements (current US$) in 2006 and Net Disbursements (current US$) in 2008 in Lower middle income?
Provide a short and direct response. -9.39e+06. What is the difference between the Net Disbursements (current US$) in 2007 and Net Disbursements (current US$) in 2008 in Lower middle income?
Offer a very short reply. 2.38e+07. What is the ratio of the Net Disbursements (current US$) of 2005 in Latin America(all income levels) to that in Latin America(developing only)?
Your answer should be very brief. 1. What is the ratio of the Net Disbursements (current US$) in 2006 in Latin America(all income levels) to that in Latin America(developing only)?
Offer a terse response. 1. What is the ratio of the Net Disbursements (current US$) in 2008 in Latin America(all income levels) to that in Latin America(developing only)?
Give a very brief answer. 1. What is the ratio of the Net Disbursements (current US$) in 2005 in Latin America(all income levels) to that in Least developed countries?
Offer a terse response. 0.29. What is the ratio of the Net Disbursements (current US$) in 2006 in Latin America(all income levels) to that in Least developed countries?
Provide a succinct answer. 0. What is the ratio of the Net Disbursements (current US$) in 2007 in Latin America(all income levels) to that in Least developed countries?
Make the answer very short. 5.41. What is the ratio of the Net Disbursements (current US$) of 2008 in Latin America(all income levels) to that in Least developed countries?
Provide a succinct answer. 0.04. What is the ratio of the Net Disbursements (current US$) of 2005 in Latin America(all income levels) to that in Low & middle income?
Your answer should be compact. 0.01. What is the ratio of the Net Disbursements (current US$) in 2006 in Latin America(all income levels) to that in Low & middle income?
Ensure brevity in your answer.  0. What is the ratio of the Net Disbursements (current US$) of 2007 in Latin America(all income levels) to that in Low & middle income?
Keep it short and to the point. 0.2. What is the ratio of the Net Disbursements (current US$) of 2008 in Latin America(all income levels) to that in Low & middle income?
Offer a terse response. 0.01. What is the ratio of the Net Disbursements (current US$) of 2005 in Latin America(all income levels) to that in Low income?
Keep it short and to the point. 0.36. What is the ratio of the Net Disbursements (current US$) of 2006 in Latin America(all income levels) to that in Low income?
Offer a terse response. 0.1. What is the ratio of the Net Disbursements (current US$) of 2007 in Latin America(all income levels) to that in Low income?
Ensure brevity in your answer.  7.06. What is the ratio of the Net Disbursements (current US$) of 2008 in Latin America(all income levels) to that in Low income?
Your answer should be compact. 0.11. What is the ratio of the Net Disbursements (current US$) of 2005 in Latin America(all income levels) to that in Lower middle income?
Give a very brief answer. 0.02. What is the ratio of the Net Disbursements (current US$) in 2006 in Latin America(all income levels) to that in Lower middle income?
Provide a succinct answer. 0.01. What is the ratio of the Net Disbursements (current US$) in 2007 in Latin America(all income levels) to that in Lower middle income?
Make the answer very short. 0.61. What is the ratio of the Net Disbursements (current US$) in 2008 in Latin America(all income levels) to that in Lower middle income?
Ensure brevity in your answer.  0.02. What is the ratio of the Net Disbursements (current US$) in 2005 in Latin America(developing only) to that in Least developed countries?
Provide a short and direct response. 0.29. What is the ratio of the Net Disbursements (current US$) in 2006 in Latin America(developing only) to that in Least developed countries?
Your response must be concise. 0. What is the ratio of the Net Disbursements (current US$) in 2007 in Latin America(developing only) to that in Least developed countries?
Offer a very short reply. 5.41. What is the ratio of the Net Disbursements (current US$) of 2008 in Latin America(developing only) to that in Least developed countries?
Your answer should be compact. 0.04. What is the ratio of the Net Disbursements (current US$) of 2005 in Latin America(developing only) to that in Low & middle income?
Your answer should be very brief. 0.01. What is the ratio of the Net Disbursements (current US$) of 2006 in Latin America(developing only) to that in Low & middle income?
Your answer should be very brief. 0. What is the ratio of the Net Disbursements (current US$) in 2007 in Latin America(developing only) to that in Low & middle income?
Ensure brevity in your answer.  0.2. What is the ratio of the Net Disbursements (current US$) in 2008 in Latin America(developing only) to that in Low & middle income?
Provide a succinct answer. 0.01. What is the ratio of the Net Disbursements (current US$) of 2005 in Latin America(developing only) to that in Low income?
Provide a short and direct response. 0.36. What is the ratio of the Net Disbursements (current US$) in 2006 in Latin America(developing only) to that in Low income?
Provide a succinct answer. 0.1. What is the ratio of the Net Disbursements (current US$) in 2007 in Latin America(developing only) to that in Low income?
Ensure brevity in your answer.  7.05. What is the ratio of the Net Disbursements (current US$) in 2008 in Latin America(developing only) to that in Low income?
Give a very brief answer. 0.11. What is the ratio of the Net Disbursements (current US$) of 2005 in Latin America(developing only) to that in Lower middle income?
Your answer should be very brief. 0.02. What is the ratio of the Net Disbursements (current US$) in 2006 in Latin America(developing only) to that in Lower middle income?
Offer a very short reply. 0.01. What is the ratio of the Net Disbursements (current US$) of 2007 in Latin America(developing only) to that in Lower middle income?
Ensure brevity in your answer.  0.6. What is the ratio of the Net Disbursements (current US$) of 2008 in Latin America(developing only) to that in Lower middle income?
Your answer should be compact. 0.02. What is the ratio of the Net Disbursements (current US$) in 2005 in Least developed countries to that in Low & middle income?
Offer a very short reply. 0.02. What is the ratio of the Net Disbursements (current US$) in 2006 in Least developed countries to that in Low & middle income?
Offer a very short reply. 0.77. What is the ratio of the Net Disbursements (current US$) in 2007 in Least developed countries to that in Low & middle income?
Ensure brevity in your answer.  0.04. What is the ratio of the Net Disbursements (current US$) of 2008 in Least developed countries to that in Low & middle income?
Make the answer very short. 0.16. What is the ratio of the Net Disbursements (current US$) in 2005 in Least developed countries to that in Low income?
Provide a short and direct response. 1.24. What is the ratio of the Net Disbursements (current US$) in 2006 in Least developed countries to that in Low income?
Give a very brief answer. 63.87. What is the ratio of the Net Disbursements (current US$) of 2007 in Least developed countries to that in Low income?
Your answer should be very brief. 1.3. What is the ratio of the Net Disbursements (current US$) of 2008 in Least developed countries to that in Low income?
Your answer should be compact. 2.56. What is the ratio of the Net Disbursements (current US$) of 2005 in Least developed countries to that in Lower middle income?
Your answer should be very brief. 0.06. What is the ratio of the Net Disbursements (current US$) of 2006 in Least developed countries to that in Lower middle income?
Provide a short and direct response. 5.06. What is the ratio of the Net Disbursements (current US$) of 2007 in Least developed countries to that in Lower middle income?
Keep it short and to the point. 0.11. What is the ratio of the Net Disbursements (current US$) of 2008 in Least developed countries to that in Lower middle income?
Your response must be concise. 0.47. What is the ratio of the Net Disbursements (current US$) of 2005 in Low & middle income to that in Low income?
Your answer should be very brief. 62.59. What is the ratio of the Net Disbursements (current US$) of 2006 in Low & middle income to that in Low income?
Give a very brief answer. 83.34. What is the ratio of the Net Disbursements (current US$) of 2007 in Low & middle income to that in Low income?
Offer a very short reply. 34.68. What is the ratio of the Net Disbursements (current US$) in 2008 in Low & middle income to that in Low income?
Give a very brief answer. 15.72. What is the ratio of the Net Disbursements (current US$) of 2005 in Low & middle income to that in Lower middle income?
Keep it short and to the point. 3.06. What is the ratio of the Net Disbursements (current US$) of 2006 in Low & middle income to that in Lower middle income?
Ensure brevity in your answer.  6.61. What is the ratio of the Net Disbursements (current US$) in 2007 in Low & middle income to that in Lower middle income?
Make the answer very short. 2.97. What is the ratio of the Net Disbursements (current US$) in 2008 in Low & middle income to that in Lower middle income?
Your response must be concise. 2.9. What is the ratio of the Net Disbursements (current US$) in 2005 in Low income to that in Lower middle income?
Provide a succinct answer. 0.05. What is the ratio of the Net Disbursements (current US$) of 2006 in Low income to that in Lower middle income?
Make the answer very short. 0.08. What is the ratio of the Net Disbursements (current US$) in 2007 in Low income to that in Lower middle income?
Ensure brevity in your answer.  0.09. What is the ratio of the Net Disbursements (current US$) of 2008 in Low income to that in Lower middle income?
Offer a terse response. 0.18. What is the difference between the highest and the second highest Net Disbursements (current US$) in 2005?
Provide a succinct answer. 3.16e+07. What is the difference between the highest and the second highest Net Disbursements (current US$) in 2006?
Your answer should be very brief. 2.86e+07. What is the difference between the highest and the second highest Net Disbursements (current US$) of 2007?
Your answer should be compact. 1.02e+08. What is the difference between the highest and the second highest Net Disbursements (current US$) in 2008?
Give a very brief answer. 5.30e+07. What is the difference between the highest and the lowest Net Disbursements (current US$) of 2005?
Give a very brief answer. 4.67e+07. What is the difference between the highest and the lowest Net Disbursements (current US$) in 2006?
Give a very brief answer. 1.22e+08. What is the difference between the highest and the lowest Net Disbursements (current US$) of 2007?
Give a very brief answer. 1.50e+08. What is the difference between the highest and the lowest Net Disbursements (current US$) in 2008?
Provide a short and direct response. 8.04e+07. 